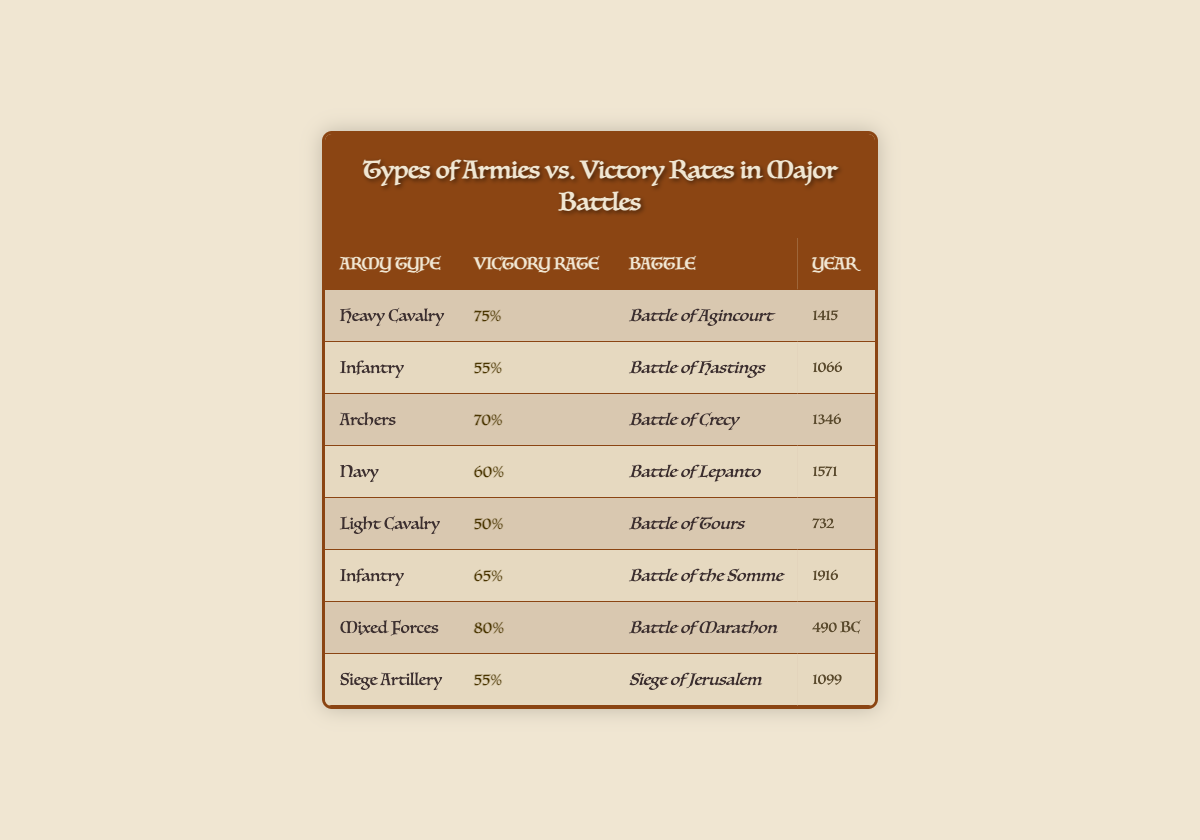What is the victory rate of Heavy Cavalry? The victory rate for Heavy Cavalry can be found in the table under the corresponding row. It shows 75% for the Battle of Agincourt in 1415.
Answer: 75% Which army type has the highest victory rate? By looking through the table, we can see 'Mixed Forces' with a victory rate of 80% for the Battle of Marathon, which is higher than all other army types presented.
Answer: Mixed Forces Is the victory rate of Navy higher than 60%? The table states a victory rate of 60% for the Navy in the Battle of Lepanto. Since it is not greater than 60%, the answer is no.
Answer: No In which year was the Battle of Hastings fought, and what was its victory rate? The Battle of Hastings is listed in the table with a year of 1066 and a victory rate of 55%. This information can be found directly across from one another in the respective row.
Answer: 1066, 55% What is the average victory rate for all army types listed in the table? To find the average, we sum up the victory rates represented as percentages (75 + 55 + 70 + 60 + 50 + 65 + 80 + 55) = 70 and divide by the total number of entries, which is 8. The total is 560/8 = 70.
Answer: 70% What is the difference between the victory rate of Archers and Light Cavalry? From the table, Archers have a victory rate of 70% and Light Cavalry has a rate of 50%. To find the difference, we subtract the two rates: 70 - 50 = 20.
Answer: 20 Was the victory rate of Infantry consistent across different battles? The table shows two instances of Infantry, one with a 55% victory rate in the Battle of Hastings and another with a 65% rate in the Battle of the Somme. Since the rates are not the same, they are inconsistent.
Answer: No Which army type did not achieve a victory rate higher than 60%? The table indicates that Light Cavalry (50%), Infantry in the Battle of Hastings (55%), and Siege Artillery (55%) do not exceed a 60% victory rate. Since multiple types don't achieve this, the answer includes all these types.
Answer: Light Cavalry, Infantry, Siege Artillery 